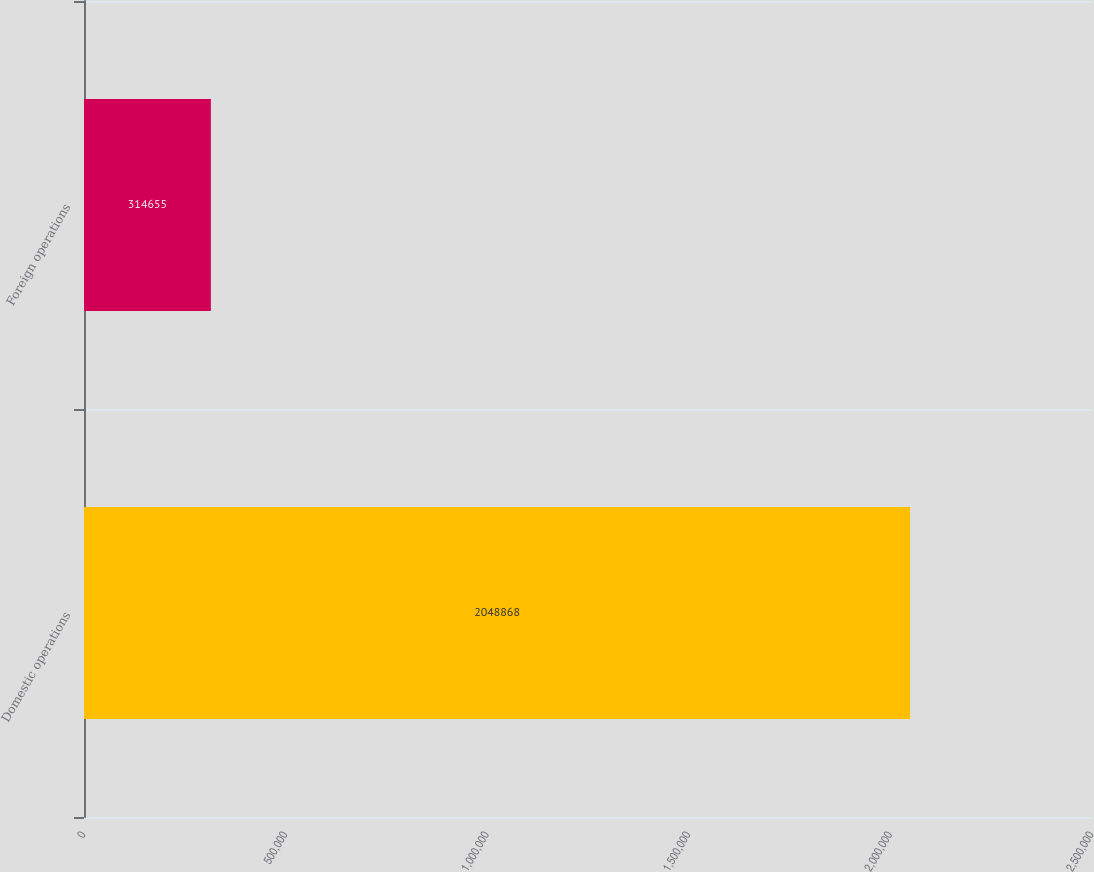Convert chart. <chart><loc_0><loc_0><loc_500><loc_500><bar_chart><fcel>Domestic operations<fcel>Foreign operations<nl><fcel>2.04887e+06<fcel>314655<nl></chart> 